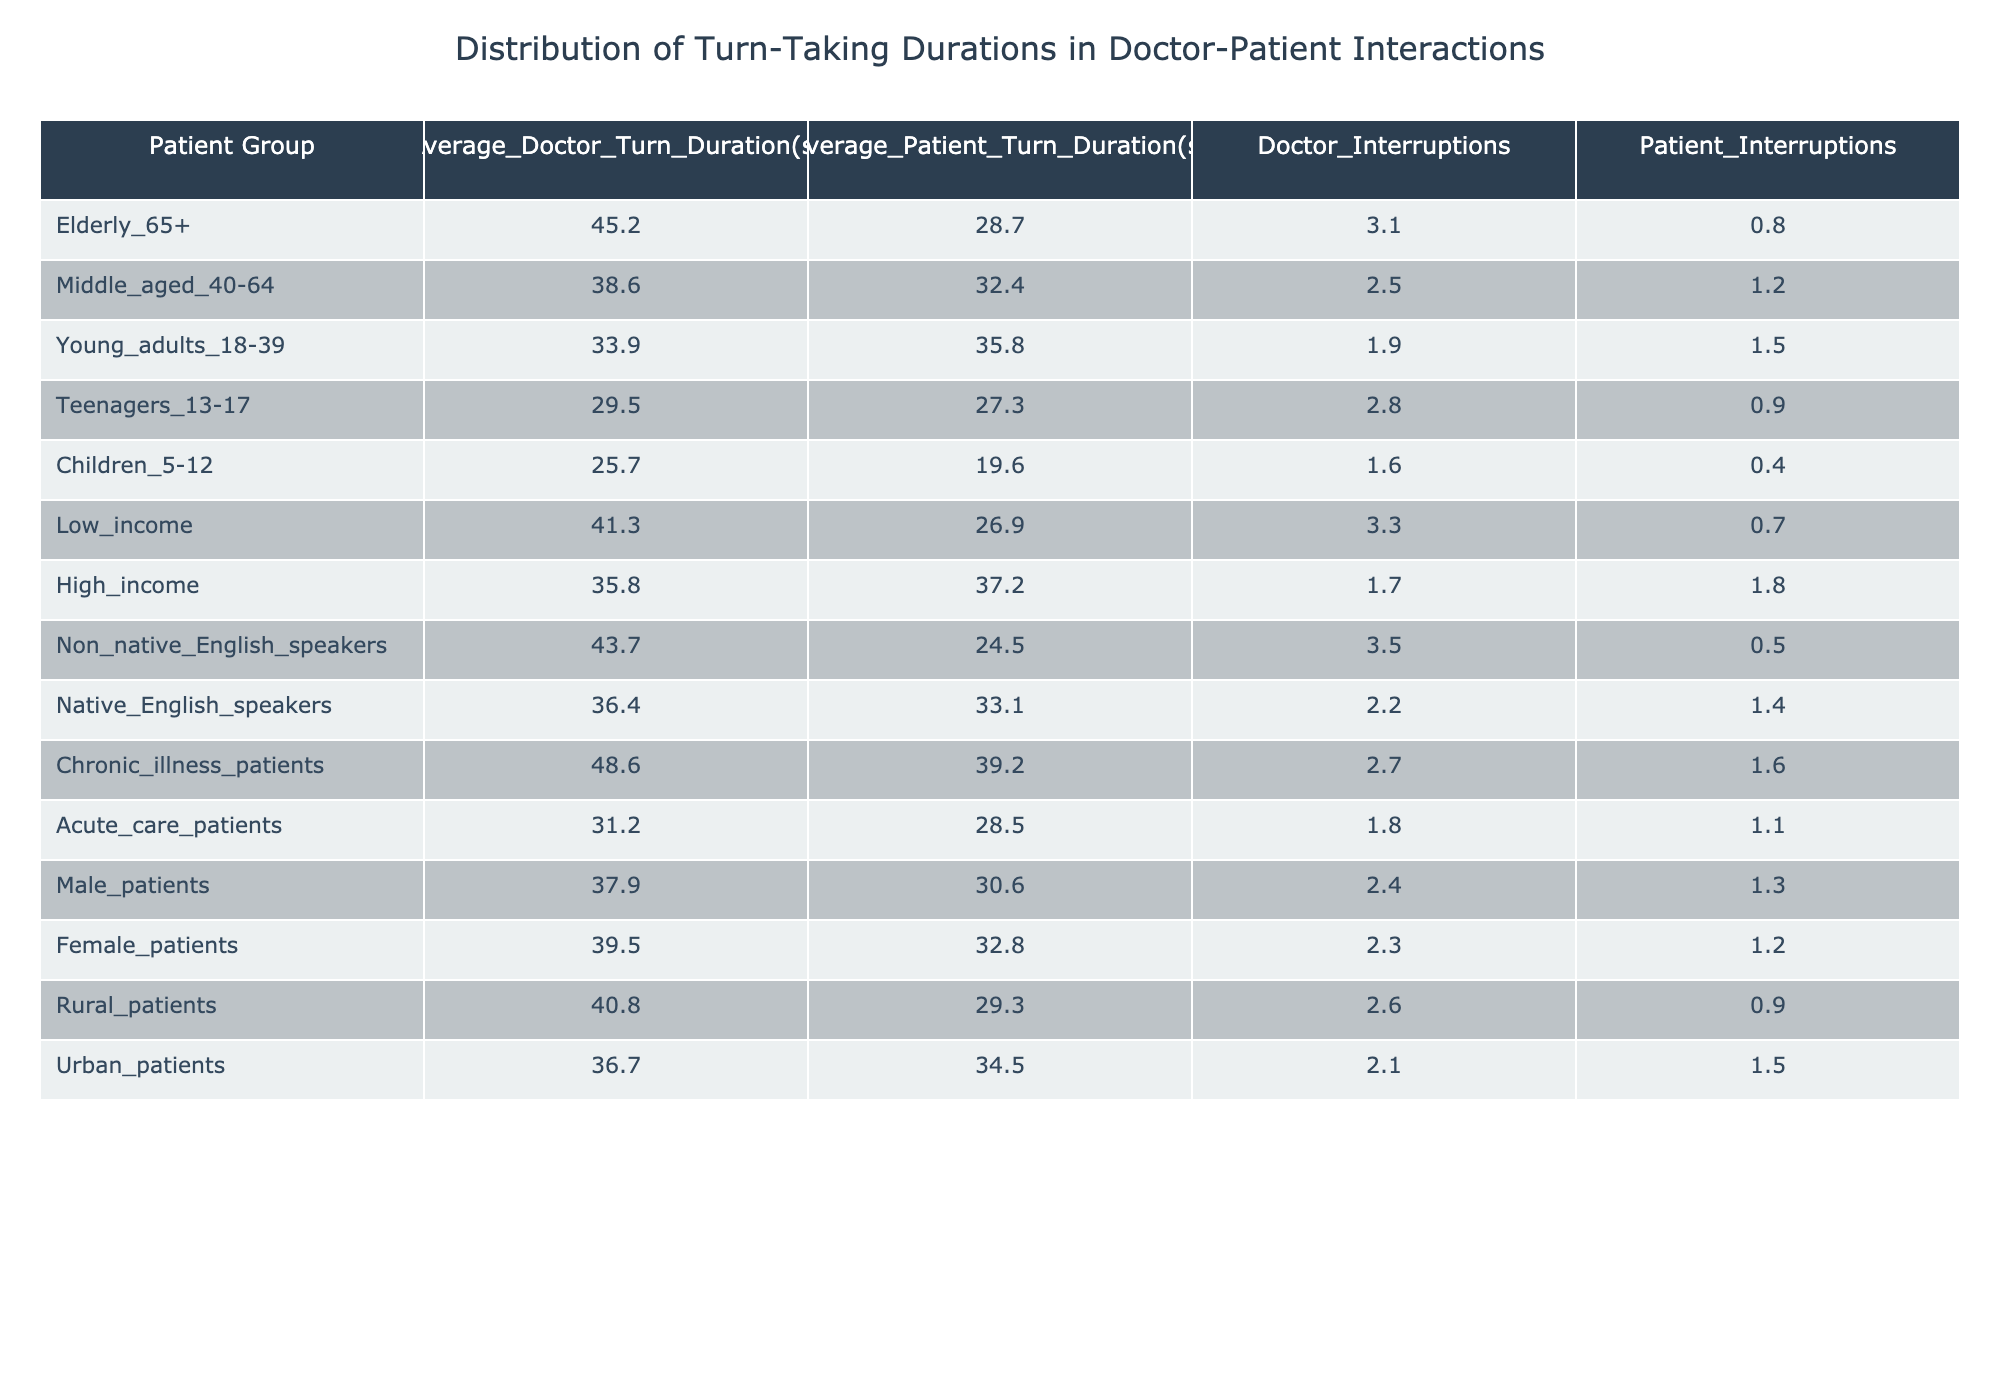What is the average doctor turn duration for elderly patients (65+)? According to the table, the value for the average doctor turn duration for elderly patients is directly listed as 45.2 seconds.
Answer: 45.2 Which patient group has the highest average patient turn duration? By looking at the patient turn duration column, 'Young adults (18-39)' has 35.8 seconds, which is the highest among all groups.
Answer: Young adults (18-39) What is the difference in average doctor turn duration between low-income and high-income patients? You can find the average doctor turn duration for low-income patients is 41.3 seconds and for high-income patients is 35.8 seconds. The difference is 41.3 - 35.8 = 5.5 seconds.
Answer: 5.5 seconds Do chronic illness patients experience more doctor interruptions than high-income patients? Chronic illness patients have 2.7 doctor interruptions while high-income patients have 1.7 interruptions. Since 2.7 is greater than 1.7, the answer is yes.
Answer: Yes Which patient demographic has the lowest average doctor turn duration? Observing the table, 'Children (5-12)' has the lowest average doctor turn duration of 25.7 seconds when compared to all the other groups.
Answer: Children (5-12) What is the average patient turn duration for non-native English speakers and how does it compare to that of rural patients? The average patient turn duration for non-native English speakers is 24.5 seconds, while for rural patients it is 29.3 seconds. Non-native English speakers have a shorter duration than rural patients.
Answer: Non-native English speakers have shorter duration Are male patients interrupted more than female patients? The table indicates that male patients experience 2.4 interruptions while female patients experience 2.3 interruptions. This shows male patients are interrupted slightly more than female patients.
Answer: Yes Calculate the average doctor turn duration across all listed patient groups. Adding up all average doctor turn durations for each patient group (45.2 + 38.6 + 33.9 + 29.5 + 25.7 + 41.3 + 35.8 + 43.7 + 36.4 + 48.6 + 31.2 + 37.9 + 39.5 + 40.8 + 36.7) gives a total of 633 seconds. Dividing this sum by 15 groups results in an average of 42.2 seconds.
Answer: 42.2 seconds What is the number of doctor interruptions for children compared to teenagers? The table shows that children have 1.6 interruptions, while teenagers have 2.8 interruptions. Teenagers have more interruptions than children.
Answer: Teenagers have more interruptions How does the average turn duration of high-income patients compare with that of teenagers? High-income patients have an average doctor turn duration of 35.8 seconds and teenagers have an average of 29.5 seconds. Therefore, high-income patients have a longer average turn duration than teenagers.
Answer: High-income patients have a longer duration 